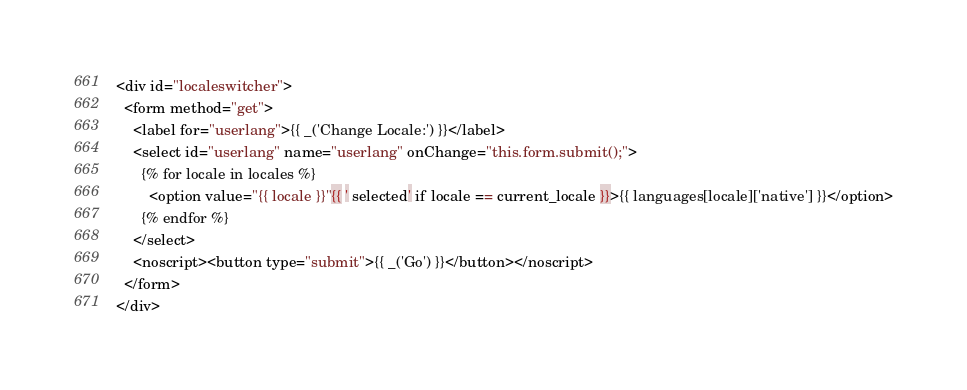<code> <loc_0><loc_0><loc_500><loc_500><_HTML_><div id="localeswitcher">
  <form method="get">
    <label for="userlang">{{ _('Change Locale:') }}</label>
    <select id="userlang" name="userlang" onChange="this.form.submit();">
      {% for locale in locales %}
        <option value="{{ locale }}"{{ ' selected' if locale == current_locale }}>{{ languages[locale]['native'] }}</option>
      {% endfor %}
    </select>
    <noscript><button type="submit">{{ _('Go') }}</button></noscript>
  </form>
</div>
</code> 